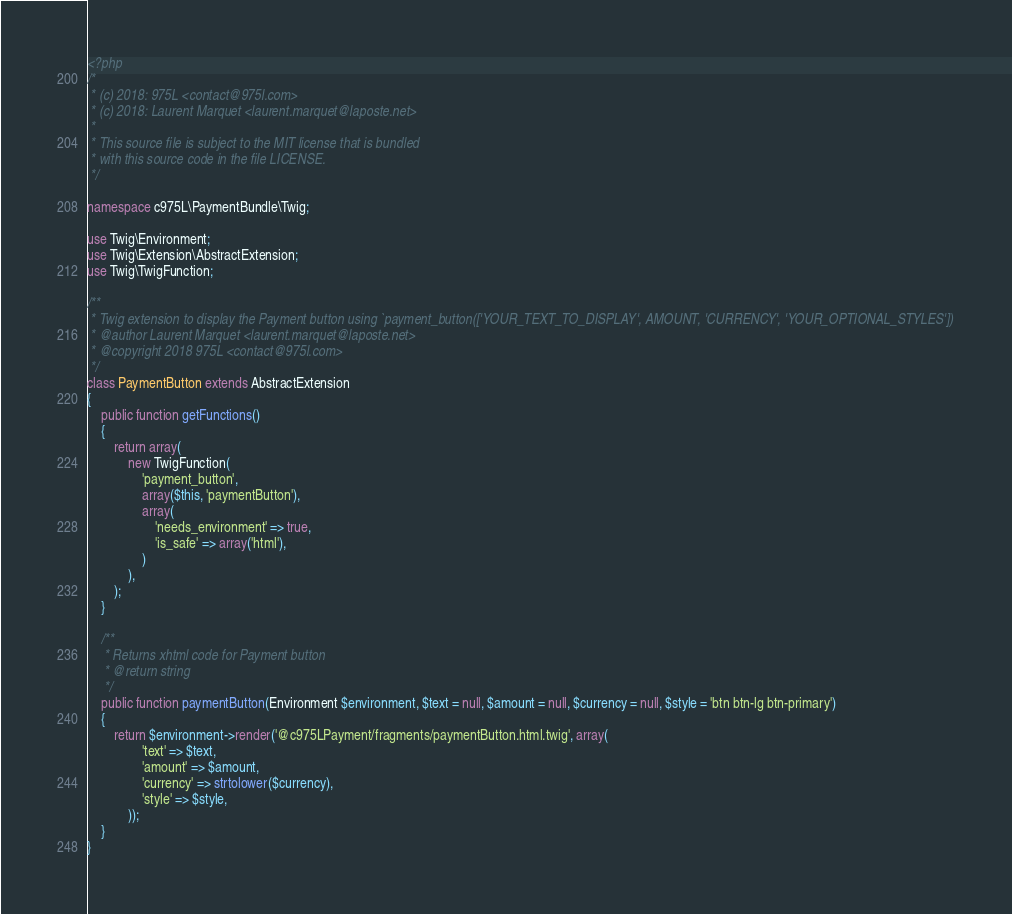Convert code to text. <code><loc_0><loc_0><loc_500><loc_500><_PHP_><?php
/*
 * (c) 2018: 975L <contact@975l.com>
 * (c) 2018: Laurent Marquet <laurent.marquet@laposte.net>
 *
 * This source file is subject to the MIT license that is bundled
 * with this source code in the file LICENSE.
 */

namespace c975L\PaymentBundle\Twig;

use Twig\Environment;
use Twig\Extension\AbstractExtension;
use Twig\TwigFunction;

/**
 * Twig extension to display the Payment button using `payment_button(['YOUR_TEXT_TO_DISPLAY', AMOUNT, 'CURRENCY', 'YOUR_OPTIONAL_STYLES'])
 * @author Laurent Marquet <laurent.marquet@laposte.net>
 * @copyright 2018 975L <contact@975l.com>
 */
class PaymentButton extends AbstractExtension
{
    public function getFunctions()
    {
        return array(
            new TwigFunction(
                'payment_button',
                array($this, 'paymentButton'),
                array(
                    'needs_environment' => true,
                    'is_safe' => array('html'),
                )
            ),
        );
    }

    /**
     * Returns xhtml code for Payment button
     * @return string
     */
    public function paymentButton(Environment $environment, $text = null, $amount = null, $currency = null, $style = 'btn btn-lg btn-primary')
    {
        return $environment->render('@c975LPayment/fragments/paymentButton.html.twig', array(
                'text' => $text,
                'amount' => $amount,
                'currency' => strtolower($currency),
                'style' => $style,
            ));
    }
}
</code> 